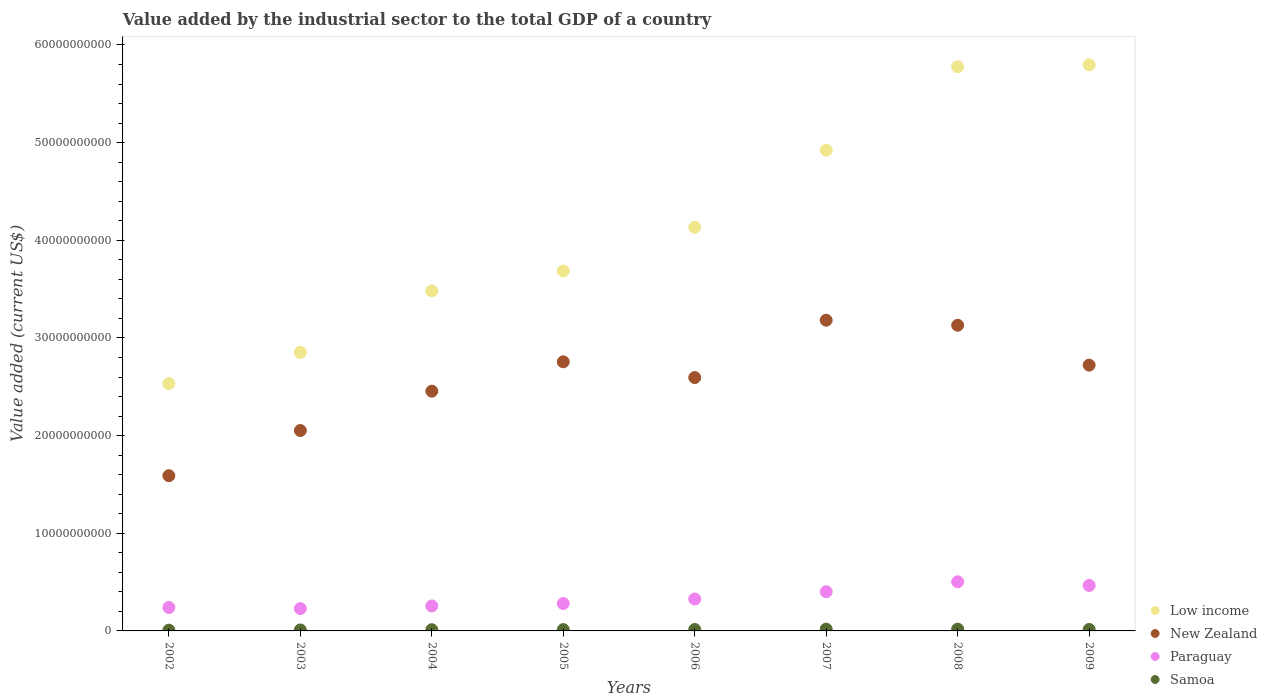How many different coloured dotlines are there?
Give a very brief answer. 4. Is the number of dotlines equal to the number of legend labels?
Your response must be concise. Yes. What is the value added by the industrial sector to the total GDP in New Zealand in 2004?
Offer a very short reply. 2.45e+1. Across all years, what is the maximum value added by the industrial sector to the total GDP in Paraguay?
Provide a short and direct response. 5.03e+09. Across all years, what is the minimum value added by the industrial sector to the total GDP in Paraguay?
Your answer should be compact. 2.29e+09. In which year was the value added by the industrial sector to the total GDP in Low income maximum?
Your answer should be very brief. 2009. What is the total value added by the industrial sector to the total GDP in Samoa in the graph?
Offer a terse response. 1.09e+09. What is the difference between the value added by the industrial sector to the total GDP in Low income in 2002 and that in 2009?
Give a very brief answer. -3.26e+1. What is the difference between the value added by the industrial sector to the total GDP in Samoa in 2003 and the value added by the industrial sector to the total GDP in Paraguay in 2007?
Your response must be concise. -3.92e+09. What is the average value added by the industrial sector to the total GDP in Samoa per year?
Make the answer very short. 1.37e+08. In the year 2009, what is the difference between the value added by the industrial sector to the total GDP in Paraguay and value added by the industrial sector to the total GDP in Low income?
Keep it short and to the point. -5.33e+1. In how many years, is the value added by the industrial sector to the total GDP in New Zealand greater than 40000000000 US$?
Offer a very short reply. 0. What is the ratio of the value added by the industrial sector to the total GDP in Paraguay in 2003 to that in 2007?
Offer a very short reply. 0.57. Is the value added by the industrial sector to the total GDP in Paraguay in 2004 less than that in 2008?
Your answer should be very brief. Yes. Is the difference between the value added by the industrial sector to the total GDP in Paraguay in 2007 and 2008 greater than the difference between the value added by the industrial sector to the total GDP in Low income in 2007 and 2008?
Keep it short and to the point. Yes. What is the difference between the highest and the second highest value added by the industrial sector to the total GDP in Samoa?
Provide a succinct answer. 6.12e+05. What is the difference between the highest and the lowest value added by the industrial sector to the total GDP in Paraguay?
Your answer should be very brief. 2.74e+09. In how many years, is the value added by the industrial sector to the total GDP in Samoa greater than the average value added by the industrial sector to the total GDP in Samoa taken over all years?
Your answer should be compact. 4. Is it the case that in every year, the sum of the value added by the industrial sector to the total GDP in Paraguay and value added by the industrial sector to the total GDP in Samoa  is greater than the sum of value added by the industrial sector to the total GDP in New Zealand and value added by the industrial sector to the total GDP in Low income?
Provide a short and direct response. No. Is it the case that in every year, the sum of the value added by the industrial sector to the total GDP in New Zealand and value added by the industrial sector to the total GDP in Samoa  is greater than the value added by the industrial sector to the total GDP in Paraguay?
Provide a succinct answer. Yes. Does the value added by the industrial sector to the total GDP in Paraguay monotonically increase over the years?
Your response must be concise. No. Is the value added by the industrial sector to the total GDP in New Zealand strictly greater than the value added by the industrial sector to the total GDP in Low income over the years?
Provide a succinct answer. No. How many dotlines are there?
Provide a short and direct response. 4. How many years are there in the graph?
Offer a terse response. 8. What is the difference between two consecutive major ticks on the Y-axis?
Ensure brevity in your answer.  1.00e+1. How are the legend labels stacked?
Your answer should be compact. Vertical. What is the title of the graph?
Your response must be concise. Value added by the industrial sector to the total GDP of a country. What is the label or title of the X-axis?
Your answer should be very brief. Years. What is the label or title of the Y-axis?
Offer a very short reply. Value added (current US$). What is the Value added (current US$) in Low income in 2002?
Give a very brief answer. 2.53e+1. What is the Value added (current US$) of New Zealand in 2002?
Make the answer very short. 1.59e+1. What is the Value added (current US$) in Paraguay in 2002?
Make the answer very short. 2.40e+09. What is the Value added (current US$) in Samoa in 2002?
Your answer should be very brief. 7.81e+07. What is the Value added (current US$) of Low income in 2003?
Provide a succinct answer. 2.85e+1. What is the Value added (current US$) of New Zealand in 2003?
Provide a succinct answer. 2.05e+1. What is the Value added (current US$) in Paraguay in 2003?
Ensure brevity in your answer.  2.29e+09. What is the Value added (current US$) of Samoa in 2003?
Your answer should be very brief. 9.86e+07. What is the Value added (current US$) of Low income in 2004?
Offer a terse response. 3.48e+1. What is the Value added (current US$) of New Zealand in 2004?
Offer a very short reply. 2.45e+1. What is the Value added (current US$) in Paraguay in 2004?
Your response must be concise. 2.56e+09. What is the Value added (current US$) of Samoa in 2004?
Keep it short and to the point. 1.23e+08. What is the Value added (current US$) of Low income in 2005?
Give a very brief answer. 3.69e+1. What is the Value added (current US$) in New Zealand in 2005?
Offer a terse response. 2.76e+1. What is the Value added (current US$) in Paraguay in 2005?
Your answer should be compact. 2.81e+09. What is the Value added (current US$) of Samoa in 2005?
Offer a terse response. 1.35e+08. What is the Value added (current US$) of Low income in 2006?
Give a very brief answer. 4.13e+1. What is the Value added (current US$) of New Zealand in 2006?
Provide a short and direct response. 2.59e+1. What is the Value added (current US$) in Paraguay in 2006?
Provide a succinct answer. 3.27e+09. What is the Value added (current US$) in Samoa in 2006?
Your response must be concise. 1.45e+08. What is the Value added (current US$) in Low income in 2007?
Provide a succinct answer. 4.92e+1. What is the Value added (current US$) of New Zealand in 2007?
Your answer should be very brief. 3.18e+1. What is the Value added (current US$) in Paraguay in 2007?
Keep it short and to the point. 4.01e+09. What is the Value added (current US$) in Samoa in 2007?
Provide a short and direct response. 1.83e+08. What is the Value added (current US$) in Low income in 2008?
Offer a very short reply. 5.78e+1. What is the Value added (current US$) in New Zealand in 2008?
Your response must be concise. 3.13e+1. What is the Value added (current US$) of Paraguay in 2008?
Your response must be concise. 5.03e+09. What is the Value added (current US$) of Samoa in 2008?
Offer a very short reply. 1.82e+08. What is the Value added (current US$) of Low income in 2009?
Keep it short and to the point. 5.80e+1. What is the Value added (current US$) in New Zealand in 2009?
Offer a very short reply. 2.72e+1. What is the Value added (current US$) of Paraguay in 2009?
Give a very brief answer. 4.66e+09. What is the Value added (current US$) of Samoa in 2009?
Your answer should be compact. 1.49e+08. Across all years, what is the maximum Value added (current US$) of Low income?
Your answer should be compact. 5.80e+1. Across all years, what is the maximum Value added (current US$) of New Zealand?
Your answer should be compact. 3.18e+1. Across all years, what is the maximum Value added (current US$) of Paraguay?
Provide a succinct answer. 5.03e+09. Across all years, what is the maximum Value added (current US$) of Samoa?
Your answer should be compact. 1.83e+08. Across all years, what is the minimum Value added (current US$) in Low income?
Your response must be concise. 2.53e+1. Across all years, what is the minimum Value added (current US$) of New Zealand?
Offer a very short reply. 1.59e+1. Across all years, what is the minimum Value added (current US$) in Paraguay?
Your answer should be very brief. 2.29e+09. Across all years, what is the minimum Value added (current US$) in Samoa?
Make the answer very short. 7.81e+07. What is the total Value added (current US$) in Low income in the graph?
Give a very brief answer. 3.32e+11. What is the total Value added (current US$) in New Zealand in the graph?
Your answer should be very brief. 2.05e+11. What is the total Value added (current US$) in Paraguay in the graph?
Provide a short and direct response. 2.70e+1. What is the total Value added (current US$) of Samoa in the graph?
Keep it short and to the point. 1.09e+09. What is the difference between the Value added (current US$) in Low income in 2002 and that in 2003?
Provide a succinct answer. -3.19e+09. What is the difference between the Value added (current US$) in New Zealand in 2002 and that in 2003?
Your response must be concise. -4.63e+09. What is the difference between the Value added (current US$) of Paraguay in 2002 and that in 2003?
Make the answer very short. 1.13e+08. What is the difference between the Value added (current US$) of Samoa in 2002 and that in 2003?
Give a very brief answer. -2.05e+07. What is the difference between the Value added (current US$) of Low income in 2002 and that in 2004?
Offer a terse response. -9.49e+09. What is the difference between the Value added (current US$) of New Zealand in 2002 and that in 2004?
Offer a very short reply. -8.65e+09. What is the difference between the Value added (current US$) of Paraguay in 2002 and that in 2004?
Provide a short and direct response. -1.56e+08. What is the difference between the Value added (current US$) in Samoa in 2002 and that in 2004?
Your response must be concise. -4.48e+07. What is the difference between the Value added (current US$) in Low income in 2002 and that in 2005?
Provide a succinct answer. -1.15e+1. What is the difference between the Value added (current US$) in New Zealand in 2002 and that in 2005?
Your answer should be compact. -1.17e+1. What is the difference between the Value added (current US$) in Paraguay in 2002 and that in 2005?
Your answer should be compact. -4.05e+08. What is the difference between the Value added (current US$) in Samoa in 2002 and that in 2005?
Offer a terse response. -5.74e+07. What is the difference between the Value added (current US$) in Low income in 2002 and that in 2006?
Make the answer very short. -1.60e+1. What is the difference between the Value added (current US$) in New Zealand in 2002 and that in 2006?
Offer a terse response. -1.00e+1. What is the difference between the Value added (current US$) in Paraguay in 2002 and that in 2006?
Provide a succinct answer. -8.67e+08. What is the difference between the Value added (current US$) in Samoa in 2002 and that in 2006?
Make the answer very short. -6.67e+07. What is the difference between the Value added (current US$) of Low income in 2002 and that in 2007?
Offer a terse response. -2.39e+1. What is the difference between the Value added (current US$) in New Zealand in 2002 and that in 2007?
Make the answer very short. -1.59e+1. What is the difference between the Value added (current US$) of Paraguay in 2002 and that in 2007?
Ensure brevity in your answer.  -1.61e+09. What is the difference between the Value added (current US$) in Samoa in 2002 and that in 2007?
Provide a succinct answer. -1.05e+08. What is the difference between the Value added (current US$) in Low income in 2002 and that in 2008?
Keep it short and to the point. -3.24e+1. What is the difference between the Value added (current US$) of New Zealand in 2002 and that in 2008?
Your answer should be compact. -1.54e+1. What is the difference between the Value added (current US$) in Paraguay in 2002 and that in 2008?
Your answer should be very brief. -2.63e+09. What is the difference between the Value added (current US$) of Samoa in 2002 and that in 2008?
Your response must be concise. -1.04e+08. What is the difference between the Value added (current US$) of Low income in 2002 and that in 2009?
Your response must be concise. -3.26e+1. What is the difference between the Value added (current US$) of New Zealand in 2002 and that in 2009?
Offer a very short reply. -1.13e+1. What is the difference between the Value added (current US$) in Paraguay in 2002 and that in 2009?
Ensure brevity in your answer.  -2.26e+09. What is the difference between the Value added (current US$) in Samoa in 2002 and that in 2009?
Provide a succinct answer. -7.10e+07. What is the difference between the Value added (current US$) of Low income in 2003 and that in 2004?
Offer a very short reply. -6.29e+09. What is the difference between the Value added (current US$) of New Zealand in 2003 and that in 2004?
Keep it short and to the point. -4.03e+09. What is the difference between the Value added (current US$) of Paraguay in 2003 and that in 2004?
Provide a succinct answer. -2.69e+08. What is the difference between the Value added (current US$) of Samoa in 2003 and that in 2004?
Your answer should be very brief. -2.42e+07. What is the difference between the Value added (current US$) of Low income in 2003 and that in 2005?
Your response must be concise. -8.33e+09. What is the difference between the Value added (current US$) of New Zealand in 2003 and that in 2005?
Offer a terse response. -7.04e+09. What is the difference between the Value added (current US$) of Paraguay in 2003 and that in 2005?
Your answer should be very brief. -5.18e+08. What is the difference between the Value added (current US$) of Samoa in 2003 and that in 2005?
Your response must be concise. -3.69e+07. What is the difference between the Value added (current US$) of Low income in 2003 and that in 2006?
Provide a short and direct response. -1.28e+1. What is the difference between the Value added (current US$) of New Zealand in 2003 and that in 2006?
Your answer should be compact. -5.42e+09. What is the difference between the Value added (current US$) of Paraguay in 2003 and that in 2006?
Offer a very short reply. -9.80e+08. What is the difference between the Value added (current US$) of Samoa in 2003 and that in 2006?
Your answer should be compact. -4.61e+07. What is the difference between the Value added (current US$) in Low income in 2003 and that in 2007?
Keep it short and to the point. -2.07e+1. What is the difference between the Value added (current US$) of New Zealand in 2003 and that in 2007?
Your answer should be very brief. -1.13e+1. What is the difference between the Value added (current US$) of Paraguay in 2003 and that in 2007?
Offer a very short reply. -1.73e+09. What is the difference between the Value added (current US$) of Samoa in 2003 and that in 2007?
Give a very brief answer. -8.41e+07. What is the difference between the Value added (current US$) of Low income in 2003 and that in 2008?
Offer a terse response. -2.92e+1. What is the difference between the Value added (current US$) in New Zealand in 2003 and that in 2008?
Offer a terse response. -1.08e+1. What is the difference between the Value added (current US$) of Paraguay in 2003 and that in 2008?
Offer a terse response. -2.74e+09. What is the difference between the Value added (current US$) in Samoa in 2003 and that in 2008?
Offer a very short reply. -8.35e+07. What is the difference between the Value added (current US$) of Low income in 2003 and that in 2009?
Offer a very short reply. -2.94e+1. What is the difference between the Value added (current US$) in New Zealand in 2003 and that in 2009?
Provide a short and direct response. -6.69e+09. What is the difference between the Value added (current US$) in Paraguay in 2003 and that in 2009?
Keep it short and to the point. -2.37e+09. What is the difference between the Value added (current US$) of Samoa in 2003 and that in 2009?
Your response must be concise. -5.05e+07. What is the difference between the Value added (current US$) of Low income in 2004 and that in 2005?
Provide a short and direct response. -2.04e+09. What is the difference between the Value added (current US$) of New Zealand in 2004 and that in 2005?
Provide a succinct answer. -3.01e+09. What is the difference between the Value added (current US$) in Paraguay in 2004 and that in 2005?
Your answer should be compact. -2.49e+08. What is the difference between the Value added (current US$) of Samoa in 2004 and that in 2005?
Offer a very short reply. -1.27e+07. What is the difference between the Value added (current US$) of Low income in 2004 and that in 2006?
Your answer should be compact. -6.51e+09. What is the difference between the Value added (current US$) of New Zealand in 2004 and that in 2006?
Keep it short and to the point. -1.40e+09. What is the difference between the Value added (current US$) in Paraguay in 2004 and that in 2006?
Make the answer very short. -7.11e+08. What is the difference between the Value added (current US$) of Samoa in 2004 and that in 2006?
Provide a short and direct response. -2.19e+07. What is the difference between the Value added (current US$) in Low income in 2004 and that in 2007?
Make the answer very short. -1.44e+1. What is the difference between the Value added (current US$) of New Zealand in 2004 and that in 2007?
Give a very brief answer. -7.27e+09. What is the difference between the Value added (current US$) in Paraguay in 2004 and that in 2007?
Your answer should be very brief. -1.46e+09. What is the difference between the Value added (current US$) of Samoa in 2004 and that in 2007?
Your answer should be compact. -5.99e+07. What is the difference between the Value added (current US$) of Low income in 2004 and that in 2008?
Provide a succinct answer. -2.29e+1. What is the difference between the Value added (current US$) of New Zealand in 2004 and that in 2008?
Offer a terse response. -6.75e+09. What is the difference between the Value added (current US$) of Paraguay in 2004 and that in 2008?
Keep it short and to the point. -2.47e+09. What is the difference between the Value added (current US$) in Samoa in 2004 and that in 2008?
Your answer should be compact. -5.93e+07. What is the difference between the Value added (current US$) in Low income in 2004 and that in 2009?
Offer a terse response. -2.31e+1. What is the difference between the Value added (current US$) of New Zealand in 2004 and that in 2009?
Your answer should be compact. -2.67e+09. What is the difference between the Value added (current US$) in Paraguay in 2004 and that in 2009?
Your answer should be very brief. -2.10e+09. What is the difference between the Value added (current US$) of Samoa in 2004 and that in 2009?
Your response must be concise. -2.63e+07. What is the difference between the Value added (current US$) in Low income in 2005 and that in 2006?
Keep it short and to the point. -4.47e+09. What is the difference between the Value added (current US$) in New Zealand in 2005 and that in 2006?
Provide a short and direct response. 1.61e+09. What is the difference between the Value added (current US$) in Paraguay in 2005 and that in 2006?
Your response must be concise. -4.62e+08. What is the difference between the Value added (current US$) in Samoa in 2005 and that in 2006?
Make the answer very short. -9.26e+06. What is the difference between the Value added (current US$) of Low income in 2005 and that in 2007?
Keep it short and to the point. -1.24e+1. What is the difference between the Value added (current US$) in New Zealand in 2005 and that in 2007?
Offer a terse response. -4.26e+09. What is the difference between the Value added (current US$) in Paraguay in 2005 and that in 2007?
Provide a short and direct response. -1.21e+09. What is the difference between the Value added (current US$) in Samoa in 2005 and that in 2007?
Provide a short and direct response. -4.72e+07. What is the difference between the Value added (current US$) in Low income in 2005 and that in 2008?
Provide a succinct answer. -2.09e+1. What is the difference between the Value added (current US$) of New Zealand in 2005 and that in 2008?
Offer a terse response. -3.74e+09. What is the difference between the Value added (current US$) in Paraguay in 2005 and that in 2008?
Make the answer very short. -2.22e+09. What is the difference between the Value added (current US$) of Samoa in 2005 and that in 2008?
Ensure brevity in your answer.  -4.66e+07. What is the difference between the Value added (current US$) of Low income in 2005 and that in 2009?
Make the answer very short. -2.11e+1. What is the difference between the Value added (current US$) in New Zealand in 2005 and that in 2009?
Your answer should be compact. 3.41e+08. What is the difference between the Value added (current US$) in Paraguay in 2005 and that in 2009?
Keep it short and to the point. -1.85e+09. What is the difference between the Value added (current US$) of Samoa in 2005 and that in 2009?
Provide a short and direct response. -1.36e+07. What is the difference between the Value added (current US$) of Low income in 2006 and that in 2007?
Provide a short and direct response. -7.89e+09. What is the difference between the Value added (current US$) of New Zealand in 2006 and that in 2007?
Ensure brevity in your answer.  -5.87e+09. What is the difference between the Value added (current US$) of Paraguay in 2006 and that in 2007?
Keep it short and to the point. -7.46e+08. What is the difference between the Value added (current US$) in Samoa in 2006 and that in 2007?
Your answer should be very brief. -3.79e+07. What is the difference between the Value added (current US$) of Low income in 2006 and that in 2008?
Your answer should be very brief. -1.64e+1. What is the difference between the Value added (current US$) of New Zealand in 2006 and that in 2008?
Provide a succinct answer. -5.36e+09. What is the difference between the Value added (current US$) of Paraguay in 2006 and that in 2008?
Your answer should be compact. -1.76e+09. What is the difference between the Value added (current US$) in Samoa in 2006 and that in 2008?
Give a very brief answer. -3.73e+07. What is the difference between the Value added (current US$) in Low income in 2006 and that in 2009?
Your answer should be very brief. -1.66e+1. What is the difference between the Value added (current US$) of New Zealand in 2006 and that in 2009?
Make the answer very short. -1.27e+09. What is the difference between the Value added (current US$) of Paraguay in 2006 and that in 2009?
Give a very brief answer. -1.39e+09. What is the difference between the Value added (current US$) in Samoa in 2006 and that in 2009?
Make the answer very short. -4.34e+06. What is the difference between the Value added (current US$) in Low income in 2007 and that in 2008?
Offer a very short reply. -8.54e+09. What is the difference between the Value added (current US$) in New Zealand in 2007 and that in 2008?
Provide a succinct answer. 5.15e+08. What is the difference between the Value added (current US$) of Paraguay in 2007 and that in 2008?
Provide a short and direct response. -1.01e+09. What is the difference between the Value added (current US$) of Samoa in 2007 and that in 2008?
Offer a terse response. 6.12e+05. What is the difference between the Value added (current US$) of Low income in 2007 and that in 2009?
Your answer should be very brief. -8.74e+09. What is the difference between the Value added (current US$) of New Zealand in 2007 and that in 2009?
Give a very brief answer. 4.60e+09. What is the difference between the Value added (current US$) in Paraguay in 2007 and that in 2009?
Provide a short and direct response. -6.45e+08. What is the difference between the Value added (current US$) in Samoa in 2007 and that in 2009?
Offer a terse response. 3.36e+07. What is the difference between the Value added (current US$) of Low income in 2008 and that in 2009?
Your response must be concise. -2.02e+08. What is the difference between the Value added (current US$) of New Zealand in 2008 and that in 2009?
Give a very brief answer. 4.08e+09. What is the difference between the Value added (current US$) of Paraguay in 2008 and that in 2009?
Keep it short and to the point. 3.70e+08. What is the difference between the Value added (current US$) in Samoa in 2008 and that in 2009?
Your response must be concise. 3.30e+07. What is the difference between the Value added (current US$) of Low income in 2002 and the Value added (current US$) of New Zealand in 2003?
Ensure brevity in your answer.  4.81e+09. What is the difference between the Value added (current US$) of Low income in 2002 and the Value added (current US$) of Paraguay in 2003?
Give a very brief answer. 2.30e+1. What is the difference between the Value added (current US$) of Low income in 2002 and the Value added (current US$) of Samoa in 2003?
Provide a short and direct response. 2.52e+1. What is the difference between the Value added (current US$) in New Zealand in 2002 and the Value added (current US$) in Paraguay in 2003?
Give a very brief answer. 1.36e+1. What is the difference between the Value added (current US$) of New Zealand in 2002 and the Value added (current US$) of Samoa in 2003?
Provide a short and direct response. 1.58e+1. What is the difference between the Value added (current US$) in Paraguay in 2002 and the Value added (current US$) in Samoa in 2003?
Your answer should be very brief. 2.30e+09. What is the difference between the Value added (current US$) of Low income in 2002 and the Value added (current US$) of New Zealand in 2004?
Your answer should be very brief. 7.81e+08. What is the difference between the Value added (current US$) in Low income in 2002 and the Value added (current US$) in Paraguay in 2004?
Your answer should be very brief. 2.28e+1. What is the difference between the Value added (current US$) in Low income in 2002 and the Value added (current US$) in Samoa in 2004?
Ensure brevity in your answer.  2.52e+1. What is the difference between the Value added (current US$) of New Zealand in 2002 and the Value added (current US$) of Paraguay in 2004?
Provide a succinct answer. 1.33e+1. What is the difference between the Value added (current US$) in New Zealand in 2002 and the Value added (current US$) in Samoa in 2004?
Your answer should be compact. 1.58e+1. What is the difference between the Value added (current US$) of Paraguay in 2002 and the Value added (current US$) of Samoa in 2004?
Your response must be concise. 2.28e+09. What is the difference between the Value added (current US$) in Low income in 2002 and the Value added (current US$) in New Zealand in 2005?
Provide a short and direct response. -2.23e+09. What is the difference between the Value added (current US$) of Low income in 2002 and the Value added (current US$) of Paraguay in 2005?
Offer a terse response. 2.25e+1. What is the difference between the Value added (current US$) in Low income in 2002 and the Value added (current US$) in Samoa in 2005?
Ensure brevity in your answer.  2.52e+1. What is the difference between the Value added (current US$) of New Zealand in 2002 and the Value added (current US$) of Paraguay in 2005?
Offer a terse response. 1.31e+1. What is the difference between the Value added (current US$) in New Zealand in 2002 and the Value added (current US$) in Samoa in 2005?
Offer a very short reply. 1.58e+1. What is the difference between the Value added (current US$) of Paraguay in 2002 and the Value added (current US$) of Samoa in 2005?
Your answer should be compact. 2.27e+09. What is the difference between the Value added (current US$) of Low income in 2002 and the Value added (current US$) of New Zealand in 2006?
Give a very brief answer. -6.14e+08. What is the difference between the Value added (current US$) of Low income in 2002 and the Value added (current US$) of Paraguay in 2006?
Make the answer very short. 2.21e+1. What is the difference between the Value added (current US$) of Low income in 2002 and the Value added (current US$) of Samoa in 2006?
Provide a succinct answer. 2.52e+1. What is the difference between the Value added (current US$) of New Zealand in 2002 and the Value added (current US$) of Paraguay in 2006?
Ensure brevity in your answer.  1.26e+1. What is the difference between the Value added (current US$) of New Zealand in 2002 and the Value added (current US$) of Samoa in 2006?
Offer a very short reply. 1.58e+1. What is the difference between the Value added (current US$) of Paraguay in 2002 and the Value added (current US$) of Samoa in 2006?
Make the answer very short. 2.26e+09. What is the difference between the Value added (current US$) of Low income in 2002 and the Value added (current US$) of New Zealand in 2007?
Keep it short and to the point. -6.48e+09. What is the difference between the Value added (current US$) of Low income in 2002 and the Value added (current US$) of Paraguay in 2007?
Make the answer very short. 2.13e+1. What is the difference between the Value added (current US$) in Low income in 2002 and the Value added (current US$) in Samoa in 2007?
Provide a short and direct response. 2.51e+1. What is the difference between the Value added (current US$) in New Zealand in 2002 and the Value added (current US$) in Paraguay in 2007?
Ensure brevity in your answer.  1.19e+1. What is the difference between the Value added (current US$) in New Zealand in 2002 and the Value added (current US$) in Samoa in 2007?
Give a very brief answer. 1.57e+1. What is the difference between the Value added (current US$) in Paraguay in 2002 and the Value added (current US$) in Samoa in 2007?
Your answer should be compact. 2.22e+09. What is the difference between the Value added (current US$) of Low income in 2002 and the Value added (current US$) of New Zealand in 2008?
Your answer should be compact. -5.97e+09. What is the difference between the Value added (current US$) of Low income in 2002 and the Value added (current US$) of Paraguay in 2008?
Your response must be concise. 2.03e+1. What is the difference between the Value added (current US$) of Low income in 2002 and the Value added (current US$) of Samoa in 2008?
Provide a short and direct response. 2.51e+1. What is the difference between the Value added (current US$) of New Zealand in 2002 and the Value added (current US$) of Paraguay in 2008?
Your answer should be very brief. 1.09e+1. What is the difference between the Value added (current US$) of New Zealand in 2002 and the Value added (current US$) of Samoa in 2008?
Provide a succinct answer. 1.57e+1. What is the difference between the Value added (current US$) in Paraguay in 2002 and the Value added (current US$) in Samoa in 2008?
Your response must be concise. 2.22e+09. What is the difference between the Value added (current US$) in Low income in 2002 and the Value added (current US$) in New Zealand in 2009?
Ensure brevity in your answer.  -1.89e+09. What is the difference between the Value added (current US$) of Low income in 2002 and the Value added (current US$) of Paraguay in 2009?
Your answer should be very brief. 2.07e+1. What is the difference between the Value added (current US$) in Low income in 2002 and the Value added (current US$) in Samoa in 2009?
Offer a very short reply. 2.52e+1. What is the difference between the Value added (current US$) of New Zealand in 2002 and the Value added (current US$) of Paraguay in 2009?
Make the answer very short. 1.12e+1. What is the difference between the Value added (current US$) of New Zealand in 2002 and the Value added (current US$) of Samoa in 2009?
Provide a short and direct response. 1.57e+1. What is the difference between the Value added (current US$) in Paraguay in 2002 and the Value added (current US$) in Samoa in 2009?
Your response must be concise. 2.25e+09. What is the difference between the Value added (current US$) in Low income in 2003 and the Value added (current US$) in New Zealand in 2004?
Offer a very short reply. 3.98e+09. What is the difference between the Value added (current US$) of Low income in 2003 and the Value added (current US$) of Paraguay in 2004?
Keep it short and to the point. 2.60e+1. What is the difference between the Value added (current US$) of Low income in 2003 and the Value added (current US$) of Samoa in 2004?
Give a very brief answer. 2.84e+1. What is the difference between the Value added (current US$) of New Zealand in 2003 and the Value added (current US$) of Paraguay in 2004?
Your answer should be very brief. 1.80e+1. What is the difference between the Value added (current US$) of New Zealand in 2003 and the Value added (current US$) of Samoa in 2004?
Your answer should be very brief. 2.04e+1. What is the difference between the Value added (current US$) in Paraguay in 2003 and the Value added (current US$) in Samoa in 2004?
Your response must be concise. 2.17e+09. What is the difference between the Value added (current US$) in Low income in 2003 and the Value added (current US$) in New Zealand in 2005?
Provide a succinct answer. 9.67e+08. What is the difference between the Value added (current US$) of Low income in 2003 and the Value added (current US$) of Paraguay in 2005?
Provide a short and direct response. 2.57e+1. What is the difference between the Value added (current US$) of Low income in 2003 and the Value added (current US$) of Samoa in 2005?
Your response must be concise. 2.84e+1. What is the difference between the Value added (current US$) of New Zealand in 2003 and the Value added (current US$) of Paraguay in 2005?
Your answer should be very brief. 1.77e+1. What is the difference between the Value added (current US$) of New Zealand in 2003 and the Value added (current US$) of Samoa in 2005?
Ensure brevity in your answer.  2.04e+1. What is the difference between the Value added (current US$) of Paraguay in 2003 and the Value added (current US$) of Samoa in 2005?
Your response must be concise. 2.15e+09. What is the difference between the Value added (current US$) in Low income in 2003 and the Value added (current US$) in New Zealand in 2006?
Offer a terse response. 2.58e+09. What is the difference between the Value added (current US$) in Low income in 2003 and the Value added (current US$) in Paraguay in 2006?
Keep it short and to the point. 2.53e+1. What is the difference between the Value added (current US$) in Low income in 2003 and the Value added (current US$) in Samoa in 2006?
Keep it short and to the point. 2.84e+1. What is the difference between the Value added (current US$) of New Zealand in 2003 and the Value added (current US$) of Paraguay in 2006?
Make the answer very short. 1.73e+1. What is the difference between the Value added (current US$) in New Zealand in 2003 and the Value added (current US$) in Samoa in 2006?
Offer a very short reply. 2.04e+1. What is the difference between the Value added (current US$) in Paraguay in 2003 and the Value added (current US$) in Samoa in 2006?
Offer a very short reply. 2.14e+09. What is the difference between the Value added (current US$) in Low income in 2003 and the Value added (current US$) in New Zealand in 2007?
Ensure brevity in your answer.  -3.29e+09. What is the difference between the Value added (current US$) in Low income in 2003 and the Value added (current US$) in Paraguay in 2007?
Provide a succinct answer. 2.45e+1. What is the difference between the Value added (current US$) of Low income in 2003 and the Value added (current US$) of Samoa in 2007?
Give a very brief answer. 2.83e+1. What is the difference between the Value added (current US$) of New Zealand in 2003 and the Value added (current US$) of Paraguay in 2007?
Provide a short and direct response. 1.65e+1. What is the difference between the Value added (current US$) in New Zealand in 2003 and the Value added (current US$) in Samoa in 2007?
Provide a succinct answer. 2.03e+1. What is the difference between the Value added (current US$) in Paraguay in 2003 and the Value added (current US$) in Samoa in 2007?
Offer a very short reply. 2.11e+09. What is the difference between the Value added (current US$) in Low income in 2003 and the Value added (current US$) in New Zealand in 2008?
Offer a terse response. -2.78e+09. What is the difference between the Value added (current US$) in Low income in 2003 and the Value added (current US$) in Paraguay in 2008?
Offer a terse response. 2.35e+1. What is the difference between the Value added (current US$) of Low income in 2003 and the Value added (current US$) of Samoa in 2008?
Your response must be concise. 2.83e+1. What is the difference between the Value added (current US$) of New Zealand in 2003 and the Value added (current US$) of Paraguay in 2008?
Give a very brief answer. 1.55e+1. What is the difference between the Value added (current US$) in New Zealand in 2003 and the Value added (current US$) in Samoa in 2008?
Provide a short and direct response. 2.03e+1. What is the difference between the Value added (current US$) in Paraguay in 2003 and the Value added (current US$) in Samoa in 2008?
Make the answer very short. 2.11e+09. What is the difference between the Value added (current US$) in Low income in 2003 and the Value added (current US$) in New Zealand in 2009?
Provide a succinct answer. 1.31e+09. What is the difference between the Value added (current US$) in Low income in 2003 and the Value added (current US$) in Paraguay in 2009?
Ensure brevity in your answer.  2.39e+1. What is the difference between the Value added (current US$) in Low income in 2003 and the Value added (current US$) in Samoa in 2009?
Offer a very short reply. 2.84e+1. What is the difference between the Value added (current US$) in New Zealand in 2003 and the Value added (current US$) in Paraguay in 2009?
Provide a short and direct response. 1.59e+1. What is the difference between the Value added (current US$) in New Zealand in 2003 and the Value added (current US$) in Samoa in 2009?
Your answer should be compact. 2.04e+1. What is the difference between the Value added (current US$) of Paraguay in 2003 and the Value added (current US$) of Samoa in 2009?
Make the answer very short. 2.14e+09. What is the difference between the Value added (current US$) of Low income in 2004 and the Value added (current US$) of New Zealand in 2005?
Provide a short and direct response. 7.26e+09. What is the difference between the Value added (current US$) of Low income in 2004 and the Value added (current US$) of Paraguay in 2005?
Make the answer very short. 3.20e+1. What is the difference between the Value added (current US$) of Low income in 2004 and the Value added (current US$) of Samoa in 2005?
Provide a short and direct response. 3.47e+1. What is the difference between the Value added (current US$) of New Zealand in 2004 and the Value added (current US$) of Paraguay in 2005?
Your answer should be very brief. 2.17e+1. What is the difference between the Value added (current US$) of New Zealand in 2004 and the Value added (current US$) of Samoa in 2005?
Keep it short and to the point. 2.44e+1. What is the difference between the Value added (current US$) of Paraguay in 2004 and the Value added (current US$) of Samoa in 2005?
Make the answer very short. 2.42e+09. What is the difference between the Value added (current US$) in Low income in 2004 and the Value added (current US$) in New Zealand in 2006?
Your answer should be compact. 8.87e+09. What is the difference between the Value added (current US$) of Low income in 2004 and the Value added (current US$) of Paraguay in 2006?
Provide a succinct answer. 3.16e+1. What is the difference between the Value added (current US$) in Low income in 2004 and the Value added (current US$) in Samoa in 2006?
Give a very brief answer. 3.47e+1. What is the difference between the Value added (current US$) in New Zealand in 2004 and the Value added (current US$) in Paraguay in 2006?
Keep it short and to the point. 2.13e+1. What is the difference between the Value added (current US$) in New Zealand in 2004 and the Value added (current US$) in Samoa in 2006?
Provide a succinct answer. 2.44e+1. What is the difference between the Value added (current US$) of Paraguay in 2004 and the Value added (current US$) of Samoa in 2006?
Ensure brevity in your answer.  2.41e+09. What is the difference between the Value added (current US$) in Low income in 2004 and the Value added (current US$) in New Zealand in 2007?
Provide a short and direct response. 3.00e+09. What is the difference between the Value added (current US$) in Low income in 2004 and the Value added (current US$) in Paraguay in 2007?
Offer a terse response. 3.08e+1. What is the difference between the Value added (current US$) of Low income in 2004 and the Value added (current US$) of Samoa in 2007?
Your answer should be compact. 3.46e+1. What is the difference between the Value added (current US$) in New Zealand in 2004 and the Value added (current US$) in Paraguay in 2007?
Offer a terse response. 2.05e+1. What is the difference between the Value added (current US$) in New Zealand in 2004 and the Value added (current US$) in Samoa in 2007?
Give a very brief answer. 2.44e+1. What is the difference between the Value added (current US$) in Paraguay in 2004 and the Value added (current US$) in Samoa in 2007?
Your response must be concise. 2.37e+09. What is the difference between the Value added (current US$) of Low income in 2004 and the Value added (current US$) of New Zealand in 2008?
Make the answer very short. 3.52e+09. What is the difference between the Value added (current US$) in Low income in 2004 and the Value added (current US$) in Paraguay in 2008?
Keep it short and to the point. 2.98e+1. What is the difference between the Value added (current US$) of Low income in 2004 and the Value added (current US$) of Samoa in 2008?
Your answer should be very brief. 3.46e+1. What is the difference between the Value added (current US$) of New Zealand in 2004 and the Value added (current US$) of Paraguay in 2008?
Ensure brevity in your answer.  1.95e+1. What is the difference between the Value added (current US$) of New Zealand in 2004 and the Value added (current US$) of Samoa in 2008?
Offer a very short reply. 2.44e+1. What is the difference between the Value added (current US$) in Paraguay in 2004 and the Value added (current US$) in Samoa in 2008?
Provide a short and direct response. 2.38e+09. What is the difference between the Value added (current US$) of Low income in 2004 and the Value added (current US$) of New Zealand in 2009?
Give a very brief answer. 7.60e+09. What is the difference between the Value added (current US$) of Low income in 2004 and the Value added (current US$) of Paraguay in 2009?
Your response must be concise. 3.02e+1. What is the difference between the Value added (current US$) of Low income in 2004 and the Value added (current US$) of Samoa in 2009?
Provide a short and direct response. 3.47e+1. What is the difference between the Value added (current US$) of New Zealand in 2004 and the Value added (current US$) of Paraguay in 2009?
Your answer should be compact. 1.99e+1. What is the difference between the Value added (current US$) of New Zealand in 2004 and the Value added (current US$) of Samoa in 2009?
Offer a very short reply. 2.44e+1. What is the difference between the Value added (current US$) of Paraguay in 2004 and the Value added (current US$) of Samoa in 2009?
Keep it short and to the point. 2.41e+09. What is the difference between the Value added (current US$) in Low income in 2005 and the Value added (current US$) in New Zealand in 2006?
Make the answer very short. 1.09e+1. What is the difference between the Value added (current US$) of Low income in 2005 and the Value added (current US$) of Paraguay in 2006?
Your answer should be very brief. 3.36e+1. What is the difference between the Value added (current US$) in Low income in 2005 and the Value added (current US$) in Samoa in 2006?
Provide a short and direct response. 3.67e+1. What is the difference between the Value added (current US$) of New Zealand in 2005 and the Value added (current US$) of Paraguay in 2006?
Keep it short and to the point. 2.43e+1. What is the difference between the Value added (current US$) in New Zealand in 2005 and the Value added (current US$) in Samoa in 2006?
Your response must be concise. 2.74e+1. What is the difference between the Value added (current US$) of Paraguay in 2005 and the Value added (current US$) of Samoa in 2006?
Make the answer very short. 2.66e+09. What is the difference between the Value added (current US$) in Low income in 2005 and the Value added (current US$) in New Zealand in 2007?
Offer a terse response. 5.04e+09. What is the difference between the Value added (current US$) of Low income in 2005 and the Value added (current US$) of Paraguay in 2007?
Your response must be concise. 3.28e+1. What is the difference between the Value added (current US$) in Low income in 2005 and the Value added (current US$) in Samoa in 2007?
Give a very brief answer. 3.67e+1. What is the difference between the Value added (current US$) in New Zealand in 2005 and the Value added (current US$) in Paraguay in 2007?
Offer a terse response. 2.35e+1. What is the difference between the Value added (current US$) of New Zealand in 2005 and the Value added (current US$) of Samoa in 2007?
Offer a terse response. 2.74e+1. What is the difference between the Value added (current US$) of Paraguay in 2005 and the Value added (current US$) of Samoa in 2007?
Make the answer very short. 2.62e+09. What is the difference between the Value added (current US$) in Low income in 2005 and the Value added (current US$) in New Zealand in 2008?
Ensure brevity in your answer.  5.56e+09. What is the difference between the Value added (current US$) in Low income in 2005 and the Value added (current US$) in Paraguay in 2008?
Give a very brief answer. 3.18e+1. What is the difference between the Value added (current US$) in Low income in 2005 and the Value added (current US$) in Samoa in 2008?
Provide a short and direct response. 3.67e+1. What is the difference between the Value added (current US$) of New Zealand in 2005 and the Value added (current US$) of Paraguay in 2008?
Ensure brevity in your answer.  2.25e+1. What is the difference between the Value added (current US$) in New Zealand in 2005 and the Value added (current US$) in Samoa in 2008?
Your answer should be compact. 2.74e+1. What is the difference between the Value added (current US$) in Paraguay in 2005 and the Value added (current US$) in Samoa in 2008?
Give a very brief answer. 2.62e+09. What is the difference between the Value added (current US$) in Low income in 2005 and the Value added (current US$) in New Zealand in 2009?
Your answer should be very brief. 9.64e+09. What is the difference between the Value added (current US$) in Low income in 2005 and the Value added (current US$) in Paraguay in 2009?
Give a very brief answer. 3.22e+1. What is the difference between the Value added (current US$) in Low income in 2005 and the Value added (current US$) in Samoa in 2009?
Offer a terse response. 3.67e+1. What is the difference between the Value added (current US$) of New Zealand in 2005 and the Value added (current US$) of Paraguay in 2009?
Ensure brevity in your answer.  2.29e+1. What is the difference between the Value added (current US$) of New Zealand in 2005 and the Value added (current US$) of Samoa in 2009?
Keep it short and to the point. 2.74e+1. What is the difference between the Value added (current US$) of Paraguay in 2005 and the Value added (current US$) of Samoa in 2009?
Provide a succinct answer. 2.66e+09. What is the difference between the Value added (current US$) of Low income in 2006 and the Value added (current US$) of New Zealand in 2007?
Keep it short and to the point. 9.51e+09. What is the difference between the Value added (current US$) of Low income in 2006 and the Value added (current US$) of Paraguay in 2007?
Offer a very short reply. 3.73e+1. What is the difference between the Value added (current US$) of Low income in 2006 and the Value added (current US$) of Samoa in 2007?
Your answer should be compact. 4.11e+1. What is the difference between the Value added (current US$) of New Zealand in 2006 and the Value added (current US$) of Paraguay in 2007?
Provide a succinct answer. 2.19e+1. What is the difference between the Value added (current US$) in New Zealand in 2006 and the Value added (current US$) in Samoa in 2007?
Your answer should be very brief. 2.58e+1. What is the difference between the Value added (current US$) in Paraguay in 2006 and the Value added (current US$) in Samoa in 2007?
Keep it short and to the point. 3.09e+09. What is the difference between the Value added (current US$) of Low income in 2006 and the Value added (current US$) of New Zealand in 2008?
Keep it short and to the point. 1.00e+1. What is the difference between the Value added (current US$) of Low income in 2006 and the Value added (current US$) of Paraguay in 2008?
Give a very brief answer. 3.63e+1. What is the difference between the Value added (current US$) of Low income in 2006 and the Value added (current US$) of Samoa in 2008?
Give a very brief answer. 4.11e+1. What is the difference between the Value added (current US$) in New Zealand in 2006 and the Value added (current US$) in Paraguay in 2008?
Make the answer very short. 2.09e+1. What is the difference between the Value added (current US$) of New Zealand in 2006 and the Value added (current US$) of Samoa in 2008?
Provide a succinct answer. 2.58e+1. What is the difference between the Value added (current US$) in Paraguay in 2006 and the Value added (current US$) in Samoa in 2008?
Make the answer very short. 3.09e+09. What is the difference between the Value added (current US$) of Low income in 2006 and the Value added (current US$) of New Zealand in 2009?
Offer a terse response. 1.41e+1. What is the difference between the Value added (current US$) in Low income in 2006 and the Value added (current US$) in Paraguay in 2009?
Ensure brevity in your answer.  3.67e+1. What is the difference between the Value added (current US$) in Low income in 2006 and the Value added (current US$) in Samoa in 2009?
Your response must be concise. 4.12e+1. What is the difference between the Value added (current US$) in New Zealand in 2006 and the Value added (current US$) in Paraguay in 2009?
Your answer should be very brief. 2.13e+1. What is the difference between the Value added (current US$) in New Zealand in 2006 and the Value added (current US$) in Samoa in 2009?
Provide a succinct answer. 2.58e+1. What is the difference between the Value added (current US$) in Paraguay in 2006 and the Value added (current US$) in Samoa in 2009?
Your response must be concise. 3.12e+09. What is the difference between the Value added (current US$) of Low income in 2007 and the Value added (current US$) of New Zealand in 2008?
Offer a terse response. 1.79e+1. What is the difference between the Value added (current US$) in Low income in 2007 and the Value added (current US$) in Paraguay in 2008?
Provide a succinct answer. 4.42e+1. What is the difference between the Value added (current US$) of Low income in 2007 and the Value added (current US$) of Samoa in 2008?
Ensure brevity in your answer.  4.90e+1. What is the difference between the Value added (current US$) of New Zealand in 2007 and the Value added (current US$) of Paraguay in 2008?
Provide a succinct answer. 2.68e+1. What is the difference between the Value added (current US$) in New Zealand in 2007 and the Value added (current US$) in Samoa in 2008?
Your answer should be compact. 3.16e+1. What is the difference between the Value added (current US$) of Paraguay in 2007 and the Value added (current US$) of Samoa in 2008?
Ensure brevity in your answer.  3.83e+09. What is the difference between the Value added (current US$) of Low income in 2007 and the Value added (current US$) of New Zealand in 2009?
Offer a very short reply. 2.20e+1. What is the difference between the Value added (current US$) of Low income in 2007 and the Value added (current US$) of Paraguay in 2009?
Your answer should be compact. 4.46e+1. What is the difference between the Value added (current US$) in Low income in 2007 and the Value added (current US$) in Samoa in 2009?
Offer a terse response. 4.91e+1. What is the difference between the Value added (current US$) of New Zealand in 2007 and the Value added (current US$) of Paraguay in 2009?
Your response must be concise. 2.72e+1. What is the difference between the Value added (current US$) of New Zealand in 2007 and the Value added (current US$) of Samoa in 2009?
Offer a terse response. 3.17e+1. What is the difference between the Value added (current US$) of Paraguay in 2007 and the Value added (current US$) of Samoa in 2009?
Give a very brief answer. 3.87e+09. What is the difference between the Value added (current US$) in Low income in 2008 and the Value added (current US$) in New Zealand in 2009?
Keep it short and to the point. 3.05e+1. What is the difference between the Value added (current US$) in Low income in 2008 and the Value added (current US$) in Paraguay in 2009?
Provide a succinct answer. 5.31e+1. What is the difference between the Value added (current US$) of Low income in 2008 and the Value added (current US$) of Samoa in 2009?
Provide a short and direct response. 5.76e+1. What is the difference between the Value added (current US$) of New Zealand in 2008 and the Value added (current US$) of Paraguay in 2009?
Your answer should be compact. 2.66e+1. What is the difference between the Value added (current US$) of New Zealand in 2008 and the Value added (current US$) of Samoa in 2009?
Offer a very short reply. 3.12e+1. What is the difference between the Value added (current US$) of Paraguay in 2008 and the Value added (current US$) of Samoa in 2009?
Ensure brevity in your answer.  4.88e+09. What is the average Value added (current US$) of Low income per year?
Ensure brevity in your answer.  4.15e+1. What is the average Value added (current US$) in New Zealand per year?
Your answer should be compact. 2.56e+1. What is the average Value added (current US$) in Paraguay per year?
Keep it short and to the point. 3.38e+09. What is the average Value added (current US$) in Samoa per year?
Offer a very short reply. 1.37e+08. In the year 2002, what is the difference between the Value added (current US$) in Low income and Value added (current US$) in New Zealand?
Ensure brevity in your answer.  9.44e+09. In the year 2002, what is the difference between the Value added (current US$) of Low income and Value added (current US$) of Paraguay?
Provide a succinct answer. 2.29e+1. In the year 2002, what is the difference between the Value added (current US$) in Low income and Value added (current US$) in Samoa?
Your answer should be very brief. 2.53e+1. In the year 2002, what is the difference between the Value added (current US$) of New Zealand and Value added (current US$) of Paraguay?
Provide a short and direct response. 1.35e+1. In the year 2002, what is the difference between the Value added (current US$) of New Zealand and Value added (current US$) of Samoa?
Your response must be concise. 1.58e+1. In the year 2002, what is the difference between the Value added (current US$) in Paraguay and Value added (current US$) in Samoa?
Your answer should be compact. 2.32e+09. In the year 2003, what is the difference between the Value added (current US$) of Low income and Value added (current US$) of New Zealand?
Your answer should be very brief. 8.00e+09. In the year 2003, what is the difference between the Value added (current US$) of Low income and Value added (current US$) of Paraguay?
Your answer should be very brief. 2.62e+1. In the year 2003, what is the difference between the Value added (current US$) in Low income and Value added (current US$) in Samoa?
Ensure brevity in your answer.  2.84e+1. In the year 2003, what is the difference between the Value added (current US$) of New Zealand and Value added (current US$) of Paraguay?
Provide a succinct answer. 1.82e+1. In the year 2003, what is the difference between the Value added (current US$) of New Zealand and Value added (current US$) of Samoa?
Offer a terse response. 2.04e+1. In the year 2003, what is the difference between the Value added (current US$) of Paraguay and Value added (current US$) of Samoa?
Give a very brief answer. 2.19e+09. In the year 2004, what is the difference between the Value added (current US$) in Low income and Value added (current US$) in New Zealand?
Your answer should be compact. 1.03e+1. In the year 2004, what is the difference between the Value added (current US$) in Low income and Value added (current US$) in Paraguay?
Ensure brevity in your answer.  3.23e+1. In the year 2004, what is the difference between the Value added (current US$) of Low income and Value added (current US$) of Samoa?
Provide a succinct answer. 3.47e+1. In the year 2004, what is the difference between the Value added (current US$) of New Zealand and Value added (current US$) of Paraguay?
Your answer should be very brief. 2.20e+1. In the year 2004, what is the difference between the Value added (current US$) of New Zealand and Value added (current US$) of Samoa?
Your answer should be very brief. 2.44e+1. In the year 2004, what is the difference between the Value added (current US$) of Paraguay and Value added (current US$) of Samoa?
Keep it short and to the point. 2.43e+09. In the year 2005, what is the difference between the Value added (current US$) of Low income and Value added (current US$) of New Zealand?
Your response must be concise. 9.30e+09. In the year 2005, what is the difference between the Value added (current US$) of Low income and Value added (current US$) of Paraguay?
Offer a very short reply. 3.41e+1. In the year 2005, what is the difference between the Value added (current US$) of Low income and Value added (current US$) of Samoa?
Give a very brief answer. 3.67e+1. In the year 2005, what is the difference between the Value added (current US$) in New Zealand and Value added (current US$) in Paraguay?
Give a very brief answer. 2.48e+1. In the year 2005, what is the difference between the Value added (current US$) in New Zealand and Value added (current US$) in Samoa?
Provide a succinct answer. 2.74e+1. In the year 2005, what is the difference between the Value added (current US$) in Paraguay and Value added (current US$) in Samoa?
Your response must be concise. 2.67e+09. In the year 2006, what is the difference between the Value added (current US$) in Low income and Value added (current US$) in New Zealand?
Keep it short and to the point. 1.54e+1. In the year 2006, what is the difference between the Value added (current US$) of Low income and Value added (current US$) of Paraguay?
Ensure brevity in your answer.  3.81e+1. In the year 2006, what is the difference between the Value added (current US$) in Low income and Value added (current US$) in Samoa?
Give a very brief answer. 4.12e+1. In the year 2006, what is the difference between the Value added (current US$) in New Zealand and Value added (current US$) in Paraguay?
Your answer should be compact. 2.27e+1. In the year 2006, what is the difference between the Value added (current US$) of New Zealand and Value added (current US$) of Samoa?
Offer a very short reply. 2.58e+1. In the year 2006, what is the difference between the Value added (current US$) of Paraguay and Value added (current US$) of Samoa?
Offer a very short reply. 3.12e+09. In the year 2007, what is the difference between the Value added (current US$) of Low income and Value added (current US$) of New Zealand?
Provide a succinct answer. 1.74e+1. In the year 2007, what is the difference between the Value added (current US$) of Low income and Value added (current US$) of Paraguay?
Make the answer very short. 4.52e+1. In the year 2007, what is the difference between the Value added (current US$) of Low income and Value added (current US$) of Samoa?
Keep it short and to the point. 4.90e+1. In the year 2007, what is the difference between the Value added (current US$) in New Zealand and Value added (current US$) in Paraguay?
Offer a very short reply. 2.78e+1. In the year 2007, what is the difference between the Value added (current US$) of New Zealand and Value added (current US$) of Samoa?
Your answer should be very brief. 3.16e+1. In the year 2007, what is the difference between the Value added (current US$) of Paraguay and Value added (current US$) of Samoa?
Offer a very short reply. 3.83e+09. In the year 2008, what is the difference between the Value added (current US$) in Low income and Value added (current US$) in New Zealand?
Your answer should be very brief. 2.65e+1. In the year 2008, what is the difference between the Value added (current US$) in Low income and Value added (current US$) in Paraguay?
Your answer should be compact. 5.27e+1. In the year 2008, what is the difference between the Value added (current US$) in Low income and Value added (current US$) in Samoa?
Offer a terse response. 5.76e+1. In the year 2008, what is the difference between the Value added (current US$) of New Zealand and Value added (current US$) of Paraguay?
Provide a short and direct response. 2.63e+1. In the year 2008, what is the difference between the Value added (current US$) in New Zealand and Value added (current US$) in Samoa?
Provide a succinct answer. 3.11e+1. In the year 2008, what is the difference between the Value added (current US$) in Paraguay and Value added (current US$) in Samoa?
Provide a succinct answer. 4.85e+09. In the year 2009, what is the difference between the Value added (current US$) of Low income and Value added (current US$) of New Zealand?
Keep it short and to the point. 3.07e+1. In the year 2009, what is the difference between the Value added (current US$) in Low income and Value added (current US$) in Paraguay?
Make the answer very short. 5.33e+1. In the year 2009, what is the difference between the Value added (current US$) of Low income and Value added (current US$) of Samoa?
Your response must be concise. 5.78e+1. In the year 2009, what is the difference between the Value added (current US$) of New Zealand and Value added (current US$) of Paraguay?
Provide a succinct answer. 2.26e+1. In the year 2009, what is the difference between the Value added (current US$) of New Zealand and Value added (current US$) of Samoa?
Provide a short and direct response. 2.71e+1. In the year 2009, what is the difference between the Value added (current US$) of Paraguay and Value added (current US$) of Samoa?
Give a very brief answer. 4.51e+09. What is the ratio of the Value added (current US$) of Low income in 2002 to that in 2003?
Your response must be concise. 0.89. What is the ratio of the Value added (current US$) of New Zealand in 2002 to that in 2003?
Provide a short and direct response. 0.77. What is the ratio of the Value added (current US$) in Paraguay in 2002 to that in 2003?
Offer a terse response. 1.05. What is the ratio of the Value added (current US$) of Samoa in 2002 to that in 2003?
Make the answer very short. 0.79. What is the ratio of the Value added (current US$) of Low income in 2002 to that in 2004?
Ensure brevity in your answer.  0.73. What is the ratio of the Value added (current US$) in New Zealand in 2002 to that in 2004?
Ensure brevity in your answer.  0.65. What is the ratio of the Value added (current US$) in Paraguay in 2002 to that in 2004?
Your answer should be compact. 0.94. What is the ratio of the Value added (current US$) in Samoa in 2002 to that in 2004?
Keep it short and to the point. 0.64. What is the ratio of the Value added (current US$) of Low income in 2002 to that in 2005?
Offer a very short reply. 0.69. What is the ratio of the Value added (current US$) in New Zealand in 2002 to that in 2005?
Make the answer very short. 0.58. What is the ratio of the Value added (current US$) of Paraguay in 2002 to that in 2005?
Offer a terse response. 0.86. What is the ratio of the Value added (current US$) of Samoa in 2002 to that in 2005?
Provide a short and direct response. 0.58. What is the ratio of the Value added (current US$) in Low income in 2002 to that in 2006?
Make the answer very short. 0.61. What is the ratio of the Value added (current US$) in New Zealand in 2002 to that in 2006?
Make the answer very short. 0.61. What is the ratio of the Value added (current US$) of Paraguay in 2002 to that in 2006?
Ensure brevity in your answer.  0.73. What is the ratio of the Value added (current US$) of Samoa in 2002 to that in 2006?
Offer a terse response. 0.54. What is the ratio of the Value added (current US$) of Low income in 2002 to that in 2007?
Offer a terse response. 0.51. What is the ratio of the Value added (current US$) of New Zealand in 2002 to that in 2007?
Ensure brevity in your answer.  0.5. What is the ratio of the Value added (current US$) in Paraguay in 2002 to that in 2007?
Make the answer very short. 0.6. What is the ratio of the Value added (current US$) of Samoa in 2002 to that in 2007?
Provide a short and direct response. 0.43. What is the ratio of the Value added (current US$) in Low income in 2002 to that in 2008?
Provide a succinct answer. 0.44. What is the ratio of the Value added (current US$) in New Zealand in 2002 to that in 2008?
Provide a succinct answer. 0.51. What is the ratio of the Value added (current US$) in Paraguay in 2002 to that in 2008?
Your response must be concise. 0.48. What is the ratio of the Value added (current US$) in Samoa in 2002 to that in 2008?
Provide a succinct answer. 0.43. What is the ratio of the Value added (current US$) of Low income in 2002 to that in 2009?
Your answer should be very brief. 0.44. What is the ratio of the Value added (current US$) of New Zealand in 2002 to that in 2009?
Make the answer very short. 0.58. What is the ratio of the Value added (current US$) of Paraguay in 2002 to that in 2009?
Offer a terse response. 0.52. What is the ratio of the Value added (current US$) in Samoa in 2002 to that in 2009?
Give a very brief answer. 0.52. What is the ratio of the Value added (current US$) of Low income in 2003 to that in 2004?
Provide a succinct answer. 0.82. What is the ratio of the Value added (current US$) of New Zealand in 2003 to that in 2004?
Your answer should be compact. 0.84. What is the ratio of the Value added (current US$) in Paraguay in 2003 to that in 2004?
Provide a short and direct response. 0.89. What is the ratio of the Value added (current US$) in Samoa in 2003 to that in 2004?
Offer a very short reply. 0.8. What is the ratio of the Value added (current US$) of Low income in 2003 to that in 2005?
Offer a terse response. 0.77. What is the ratio of the Value added (current US$) of New Zealand in 2003 to that in 2005?
Your answer should be very brief. 0.74. What is the ratio of the Value added (current US$) in Paraguay in 2003 to that in 2005?
Make the answer very short. 0.82. What is the ratio of the Value added (current US$) in Samoa in 2003 to that in 2005?
Your answer should be compact. 0.73. What is the ratio of the Value added (current US$) in Low income in 2003 to that in 2006?
Provide a succinct answer. 0.69. What is the ratio of the Value added (current US$) in New Zealand in 2003 to that in 2006?
Give a very brief answer. 0.79. What is the ratio of the Value added (current US$) of Paraguay in 2003 to that in 2006?
Provide a short and direct response. 0.7. What is the ratio of the Value added (current US$) in Samoa in 2003 to that in 2006?
Offer a very short reply. 0.68. What is the ratio of the Value added (current US$) of Low income in 2003 to that in 2007?
Give a very brief answer. 0.58. What is the ratio of the Value added (current US$) in New Zealand in 2003 to that in 2007?
Your response must be concise. 0.65. What is the ratio of the Value added (current US$) in Paraguay in 2003 to that in 2007?
Offer a terse response. 0.57. What is the ratio of the Value added (current US$) in Samoa in 2003 to that in 2007?
Provide a succinct answer. 0.54. What is the ratio of the Value added (current US$) in Low income in 2003 to that in 2008?
Your answer should be very brief. 0.49. What is the ratio of the Value added (current US$) in New Zealand in 2003 to that in 2008?
Your response must be concise. 0.66. What is the ratio of the Value added (current US$) of Paraguay in 2003 to that in 2008?
Your answer should be compact. 0.45. What is the ratio of the Value added (current US$) in Samoa in 2003 to that in 2008?
Keep it short and to the point. 0.54. What is the ratio of the Value added (current US$) of Low income in 2003 to that in 2009?
Give a very brief answer. 0.49. What is the ratio of the Value added (current US$) in New Zealand in 2003 to that in 2009?
Keep it short and to the point. 0.75. What is the ratio of the Value added (current US$) in Paraguay in 2003 to that in 2009?
Offer a very short reply. 0.49. What is the ratio of the Value added (current US$) in Samoa in 2003 to that in 2009?
Make the answer very short. 0.66. What is the ratio of the Value added (current US$) of Low income in 2004 to that in 2005?
Your answer should be very brief. 0.94. What is the ratio of the Value added (current US$) in New Zealand in 2004 to that in 2005?
Offer a very short reply. 0.89. What is the ratio of the Value added (current US$) in Paraguay in 2004 to that in 2005?
Provide a succinct answer. 0.91. What is the ratio of the Value added (current US$) in Samoa in 2004 to that in 2005?
Provide a succinct answer. 0.91. What is the ratio of the Value added (current US$) in Low income in 2004 to that in 2006?
Ensure brevity in your answer.  0.84. What is the ratio of the Value added (current US$) in New Zealand in 2004 to that in 2006?
Make the answer very short. 0.95. What is the ratio of the Value added (current US$) of Paraguay in 2004 to that in 2006?
Provide a short and direct response. 0.78. What is the ratio of the Value added (current US$) of Samoa in 2004 to that in 2006?
Offer a terse response. 0.85. What is the ratio of the Value added (current US$) of Low income in 2004 to that in 2007?
Give a very brief answer. 0.71. What is the ratio of the Value added (current US$) of New Zealand in 2004 to that in 2007?
Offer a very short reply. 0.77. What is the ratio of the Value added (current US$) of Paraguay in 2004 to that in 2007?
Give a very brief answer. 0.64. What is the ratio of the Value added (current US$) in Samoa in 2004 to that in 2007?
Keep it short and to the point. 0.67. What is the ratio of the Value added (current US$) in Low income in 2004 to that in 2008?
Your answer should be compact. 0.6. What is the ratio of the Value added (current US$) of New Zealand in 2004 to that in 2008?
Your response must be concise. 0.78. What is the ratio of the Value added (current US$) of Paraguay in 2004 to that in 2008?
Offer a very short reply. 0.51. What is the ratio of the Value added (current US$) in Samoa in 2004 to that in 2008?
Make the answer very short. 0.67. What is the ratio of the Value added (current US$) of Low income in 2004 to that in 2009?
Keep it short and to the point. 0.6. What is the ratio of the Value added (current US$) in New Zealand in 2004 to that in 2009?
Your response must be concise. 0.9. What is the ratio of the Value added (current US$) of Paraguay in 2004 to that in 2009?
Keep it short and to the point. 0.55. What is the ratio of the Value added (current US$) of Samoa in 2004 to that in 2009?
Give a very brief answer. 0.82. What is the ratio of the Value added (current US$) in Low income in 2005 to that in 2006?
Your answer should be very brief. 0.89. What is the ratio of the Value added (current US$) in New Zealand in 2005 to that in 2006?
Ensure brevity in your answer.  1.06. What is the ratio of the Value added (current US$) of Paraguay in 2005 to that in 2006?
Your answer should be compact. 0.86. What is the ratio of the Value added (current US$) of Samoa in 2005 to that in 2006?
Offer a terse response. 0.94. What is the ratio of the Value added (current US$) in Low income in 2005 to that in 2007?
Give a very brief answer. 0.75. What is the ratio of the Value added (current US$) of New Zealand in 2005 to that in 2007?
Offer a terse response. 0.87. What is the ratio of the Value added (current US$) of Paraguay in 2005 to that in 2007?
Offer a terse response. 0.7. What is the ratio of the Value added (current US$) in Samoa in 2005 to that in 2007?
Offer a terse response. 0.74. What is the ratio of the Value added (current US$) of Low income in 2005 to that in 2008?
Your answer should be very brief. 0.64. What is the ratio of the Value added (current US$) in New Zealand in 2005 to that in 2008?
Give a very brief answer. 0.88. What is the ratio of the Value added (current US$) of Paraguay in 2005 to that in 2008?
Offer a very short reply. 0.56. What is the ratio of the Value added (current US$) in Samoa in 2005 to that in 2008?
Give a very brief answer. 0.74. What is the ratio of the Value added (current US$) of Low income in 2005 to that in 2009?
Give a very brief answer. 0.64. What is the ratio of the Value added (current US$) of New Zealand in 2005 to that in 2009?
Give a very brief answer. 1.01. What is the ratio of the Value added (current US$) of Paraguay in 2005 to that in 2009?
Offer a terse response. 0.6. What is the ratio of the Value added (current US$) in Samoa in 2005 to that in 2009?
Provide a succinct answer. 0.91. What is the ratio of the Value added (current US$) in Low income in 2006 to that in 2007?
Provide a short and direct response. 0.84. What is the ratio of the Value added (current US$) in New Zealand in 2006 to that in 2007?
Offer a terse response. 0.82. What is the ratio of the Value added (current US$) of Paraguay in 2006 to that in 2007?
Your answer should be very brief. 0.81. What is the ratio of the Value added (current US$) of Samoa in 2006 to that in 2007?
Offer a terse response. 0.79. What is the ratio of the Value added (current US$) in Low income in 2006 to that in 2008?
Your answer should be very brief. 0.72. What is the ratio of the Value added (current US$) of New Zealand in 2006 to that in 2008?
Your answer should be compact. 0.83. What is the ratio of the Value added (current US$) of Paraguay in 2006 to that in 2008?
Make the answer very short. 0.65. What is the ratio of the Value added (current US$) in Samoa in 2006 to that in 2008?
Offer a very short reply. 0.79. What is the ratio of the Value added (current US$) in Low income in 2006 to that in 2009?
Your answer should be very brief. 0.71. What is the ratio of the Value added (current US$) of New Zealand in 2006 to that in 2009?
Ensure brevity in your answer.  0.95. What is the ratio of the Value added (current US$) of Paraguay in 2006 to that in 2009?
Offer a very short reply. 0.7. What is the ratio of the Value added (current US$) in Samoa in 2006 to that in 2009?
Your answer should be very brief. 0.97. What is the ratio of the Value added (current US$) in Low income in 2007 to that in 2008?
Your answer should be very brief. 0.85. What is the ratio of the Value added (current US$) of New Zealand in 2007 to that in 2008?
Provide a succinct answer. 1.02. What is the ratio of the Value added (current US$) in Paraguay in 2007 to that in 2008?
Keep it short and to the point. 0.8. What is the ratio of the Value added (current US$) in Samoa in 2007 to that in 2008?
Your answer should be compact. 1. What is the ratio of the Value added (current US$) in Low income in 2007 to that in 2009?
Your response must be concise. 0.85. What is the ratio of the Value added (current US$) in New Zealand in 2007 to that in 2009?
Offer a very short reply. 1.17. What is the ratio of the Value added (current US$) of Paraguay in 2007 to that in 2009?
Provide a short and direct response. 0.86. What is the ratio of the Value added (current US$) in Samoa in 2007 to that in 2009?
Ensure brevity in your answer.  1.23. What is the ratio of the Value added (current US$) of New Zealand in 2008 to that in 2009?
Give a very brief answer. 1.15. What is the ratio of the Value added (current US$) in Paraguay in 2008 to that in 2009?
Keep it short and to the point. 1.08. What is the ratio of the Value added (current US$) of Samoa in 2008 to that in 2009?
Provide a succinct answer. 1.22. What is the difference between the highest and the second highest Value added (current US$) in Low income?
Your response must be concise. 2.02e+08. What is the difference between the highest and the second highest Value added (current US$) in New Zealand?
Provide a short and direct response. 5.15e+08. What is the difference between the highest and the second highest Value added (current US$) of Paraguay?
Provide a short and direct response. 3.70e+08. What is the difference between the highest and the second highest Value added (current US$) of Samoa?
Your answer should be very brief. 6.12e+05. What is the difference between the highest and the lowest Value added (current US$) of Low income?
Your response must be concise. 3.26e+1. What is the difference between the highest and the lowest Value added (current US$) of New Zealand?
Your answer should be compact. 1.59e+1. What is the difference between the highest and the lowest Value added (current US$) in Paraguay?
Keep it short and to the point. 2.74e+09. What is the difference between the highest and the lowest Value added (current US$) of Samoa?
Provide a short and direct response. 1.05e+08. 